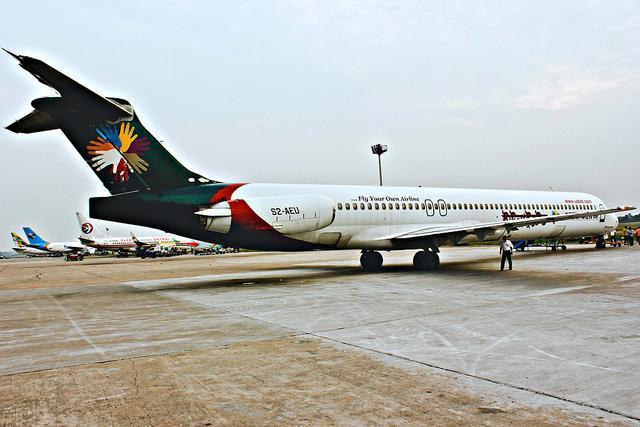How many airplanes are there?
Give a very brief answer. 1. How many motor vehicles have orange paint?
Give a very brief answer. 0. 